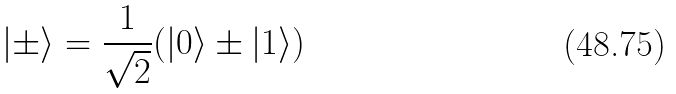Convert formula to latex. <formula><loc_0><loc_0><loc_500><loc_500>| \pm \rangle = \frac { 1 } { \sqrt { 2 } } ( | 0 \rangle \pm | 1 \rangle )</formula> 